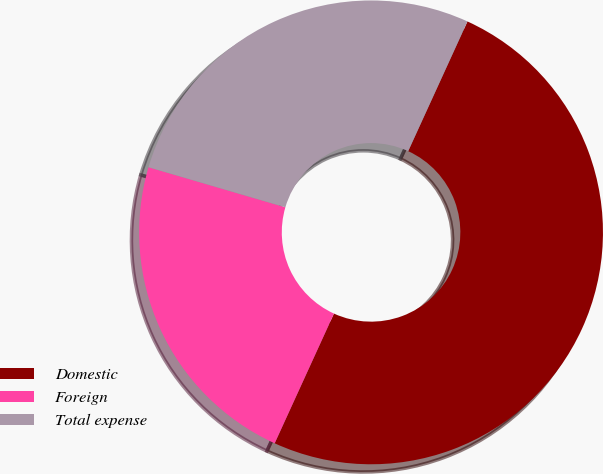<chart> <loc_0><loc_0><loc_500><loc_500><pie_chart><fcel>Domestic<fcel>Foreign<fcel>Total expense<nl><fcel>50.0%<fcel>22.71%<fcel>27.29%<nl></chart> 